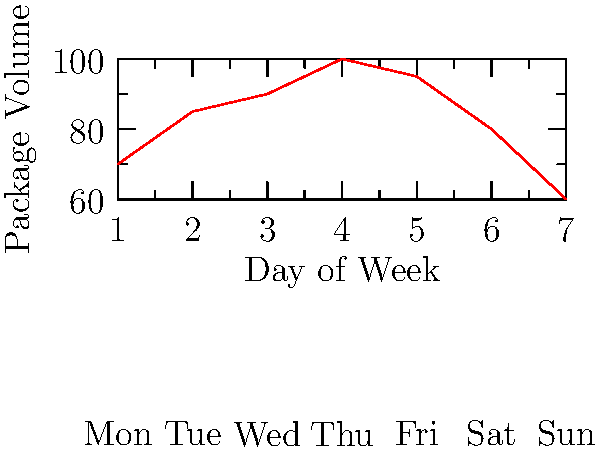Based on the graph showing package volume vs. day of the week, on which day would you recommend customers to order for the fastest delivery time, assuming processing time is inversely proportional to package volume? To determine the day with the fastest delivery time, we need to analyze the graph:

1. The graph shows package volume for each day of the week.
2. We're told that processing time is inversely proportional to package volume.
3. This means that lower package volume results in faster processing and delivery.
4. Examining the graph:
   - Monday (Day 1): Volume ≈ 70
   - Tuesday (Day 2): Volume ≈ 85
   - Wednesday (Day 3): Volume ≈ 90
   - Thursday (Day 4): Volume ≈ 100
   - Friday (Day 5): Volume ≈ 95
   - Saturday (Day 6): Volume ≈ 80
   - Sunday (Day 7): Volume ≈ 60
5. The lowest point on the graph corresponds to Sunday (Day 7).
6. Therefore, Sunday has the lowest package volume, which would result in the fastest processing and delivery time.
Answer: Sunday 